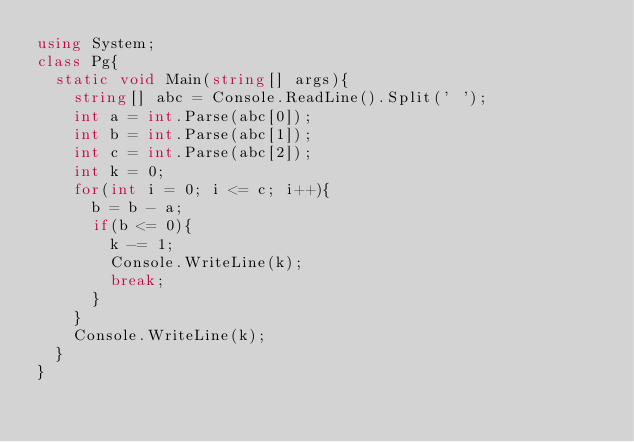Convert code to text. <code><loc_0><loc_0><loc_500><loc_500><_C#_>using System;
class Pg{
  static void Main(string[] args){
    string[] abc = Console.ReadLine().Split(' ');
    int a = int.Parse(abc[0]);
    int b = int.Parse(abc[1]);
    int c = int.Parse(abc[2]);
    int k = 0;
    for(int i = 0; i <= c; i++){
      b = b - a;
      if(b <= 0){
        k -= 1;
        Console.WriteLine(k);
        break;
      }
    }
    Console.WriteLine(k);
  }
}
</code> 